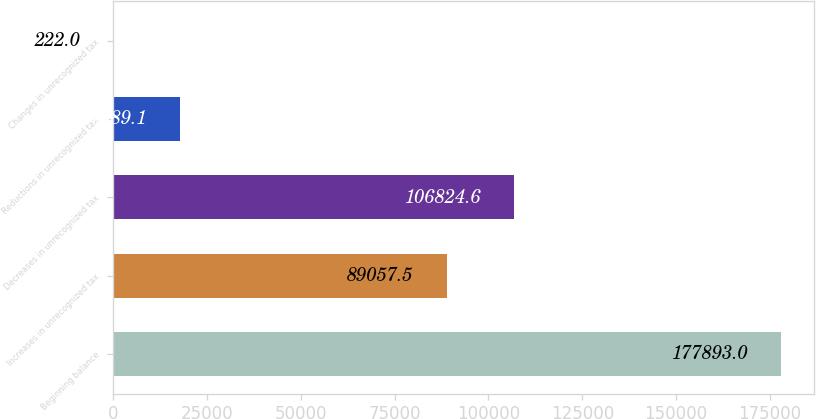<chart> <loc_0><loc_0><loc_500><loc_500><bar_chart><fcel>Beginning balance<fcel>Increases in unrecognized tax<fcel>Decreases in unrecognized tax<fcel>Reductions in unrecognized tax<fcel>Changes in unrecognized tax<nl><fcel>177893<fcel>89057.5<fcel>106825<fcel>17989.1<fcel>222<nl></chart> 